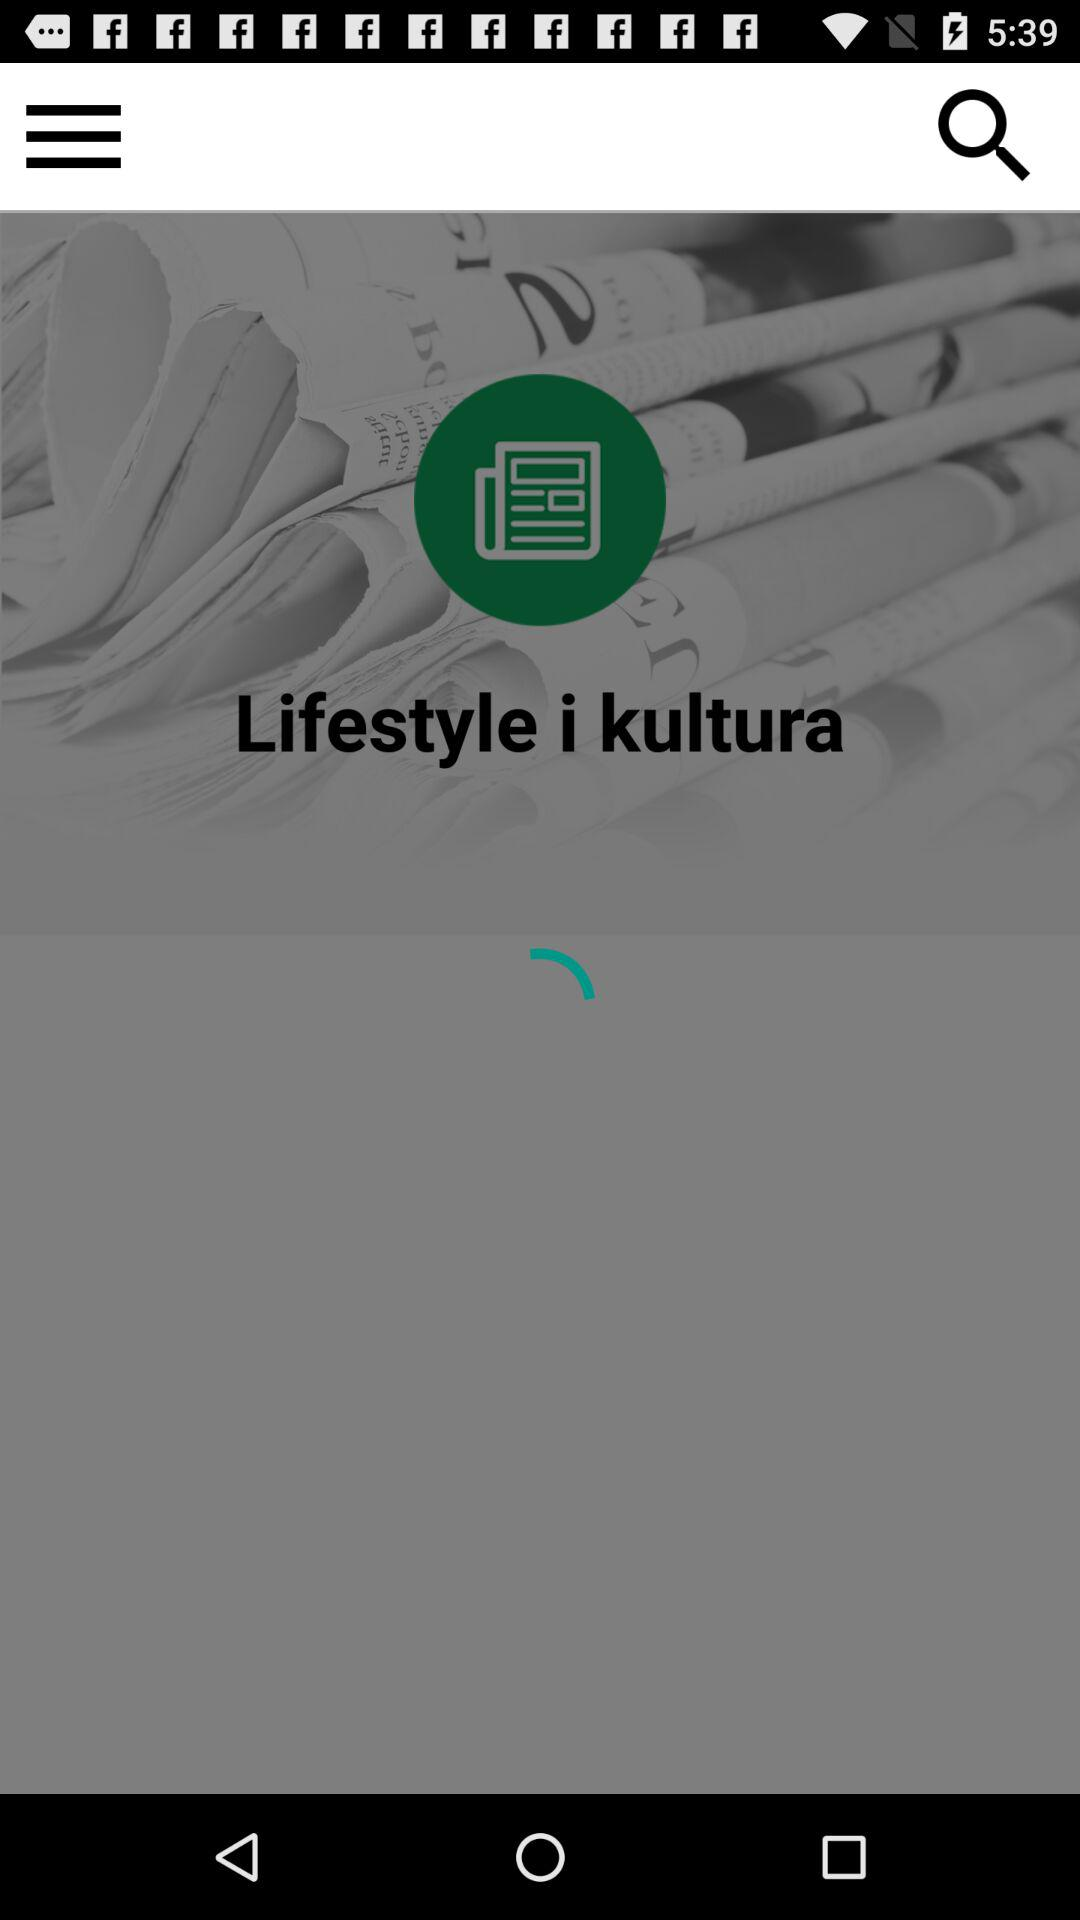What is the application name? The application name is "Lifestyle i kultura". 